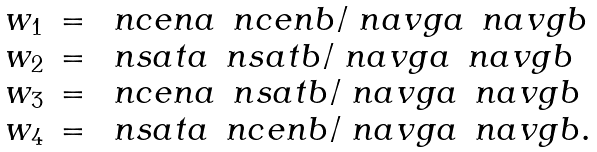<formula> <loc_0><loc_0><loc_500><loc_500>\begin{array} { l l l } w _ { 1 } & = & \ n c e n a \, \ n c e n b / \ n a v g a \, \ n a v g b \\ w _ { 2 } & = & \ n s a t a \, \ n s a t b / \ n a v g a \, \ n a v g b \\ w _ { 3 } & = & \ n c e n a \, \ n s a t b / \ n a v g a \, \ n a v g b \\ w _ { 4 } & = & \ n s a t a \, \ n c e n b / \ n a v g a \, \ n a v g b . \\ \end{array}</formula> 